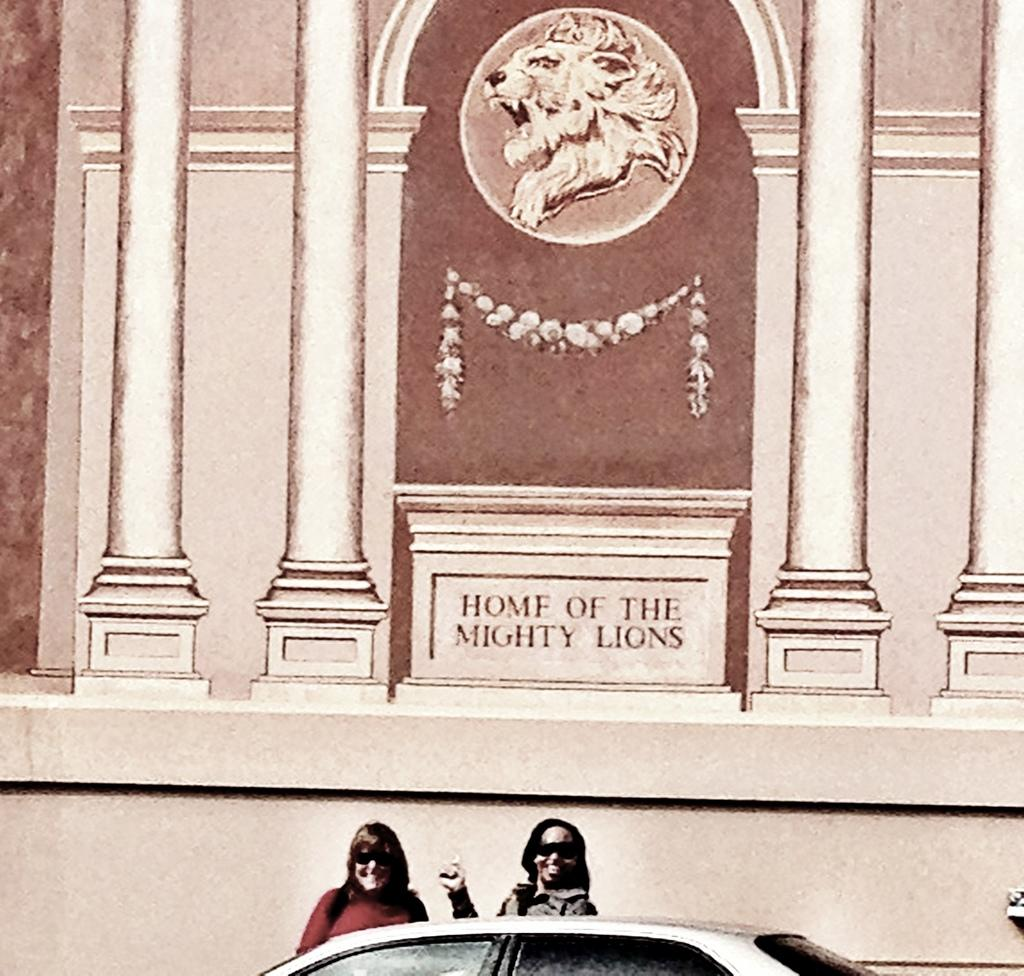What is depicted on the poster in the image? The poster features the home of a mighty lion. How many ladies are present in the image? There are two ladies in the image. What can be seen at the bottom side of the image? There is a car at the bottom side of the image. Where is the mine located in the image? There is no mine present in the image. What type of books are the ladies reading in the image? There is no indication that the ladies are reading books in the image. 